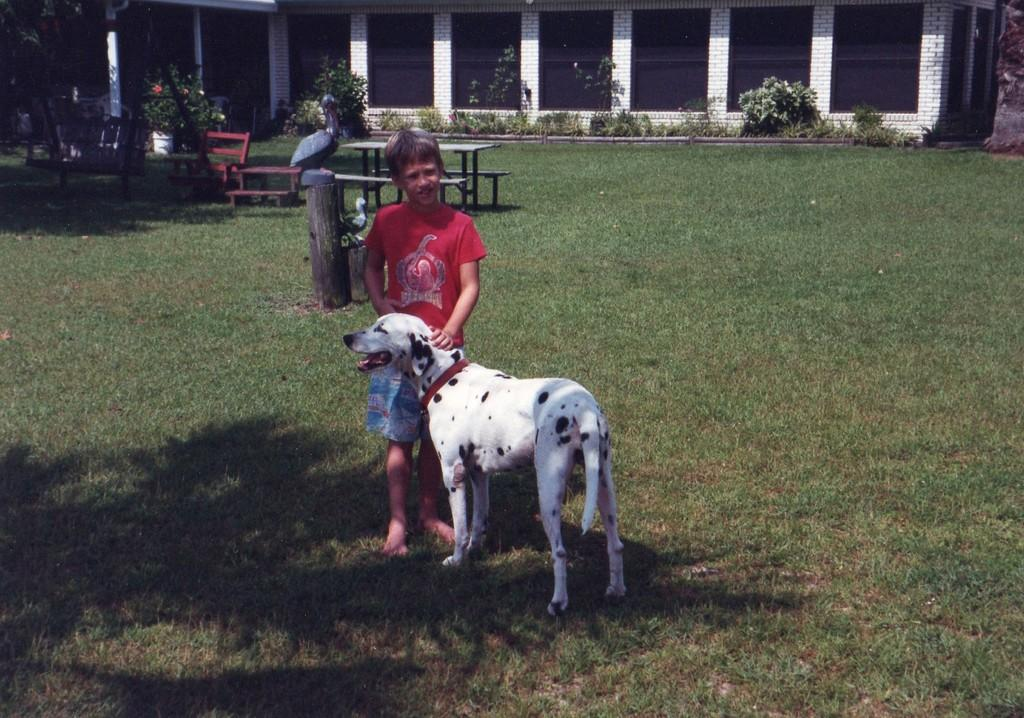What is the main subject in the center of the image? There is a dog and a boy standing in the center of the image. What can be seen in the background of the image? There is a building, a wall, plants, grass, benches, a table, pillars, and other objects in the background of the image. What type of paste is being used by the dog in the image? There is no paste present in the image; it features a dog and a boy standing together. What title does the boy hold in the image? There is no title associated with the boy in the image. 